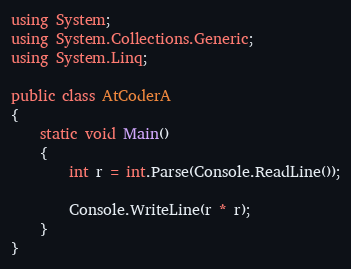Convert code to text. <code><loc_0><loc_0><loc_500><loc_500><_C#_>using System;
using System.Collections.Generic;
using System.Linq;

public class AtCoderA
{
    static void Main()
    {
        int r = int.Parse(Console.ReadLine());

        Console.WriteLine(r * r);
    }
}</code> 